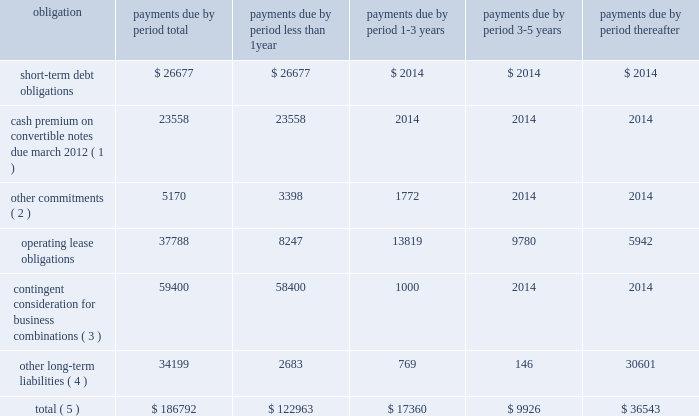Contractual cash flows following is a summary of our contractual payment obligations related to our consolidated debt , contingent consideration , operating leases , other commitments and long-term liabilities at september 30 , 2011 ( see notes 9 and 13 to the consolidated financial statements contained this annual report ) , ( in thousands ) : .
( 1 ) cash premiums related to the 201cif converted 201d value of the 2007 convertible notes that exceed aggregate principal balance using the closing stock price of $ 17.96 on september 30 , 2011 .
The actual amount of the cash premium will be calculated based on the 20 day average stock price prior to maturity .
A $ 1.00 change in our stock price would change the 201cif converted 201d value of the cash premium of the total aggregate principle amount of the remaining convertible notes by approximately $ 2.8 million .
( 2 ) other commitments consist of contractual license and royalty payments , and other purchase obligations .
( 3 ) contingent consideration related to business combinations is recorded at fair value and actual results could differ .
( 4 ) other long-term liabilities includes our gross unrecognized tax benefits , as well as executive deferred compensation which are both classified as beyond five years due to the uncertain nature of the commitment .
( 5 ) amounts do not include potential cash payments for the pending acquisition of aati .
Critical accounting estimates the discussion and analysis of our financial condition and results of operations are based upon our consolidated financial statements , which have been prepared in accordance with gaap .
The preparation of these financial statements requires us to make estimates and judgments that affect the reported amounts of assets , liabilities , revenues and expenses , and related disclosure of contingent assets and liabilities .
The sec has defined critical accounting policies as those that are both most important to the portrayal of our financial condition and results and which require our most difficult , complex or subjective judgments or estimates .
Based on this definition , we believe our critical accounting policies include the policies of revenue recognition , allowance for doubtful accounts , inventory valuation , business combinations , valuation of long-lived assets , share-based compensation , income taxes , goodwill and intangibles , and loss contingencies .
On an ongoing basis , we evaluate the judgments and estimates underlying all of our accounting policies .
These estimates and the underlying assumptions affect the amounts of assets and liabilities reported , disclosures , and reported amounts of revenues and expenses .
These estimates and assumptions are based on our best judgments .
We evaluate our estimates and assumptions using historical experience and other factors , including the current economic environment , which we believe to be reasonable under the circumstances .
We adjust such estimates and assumptions when facts and circumstances dictate .
As future events and their effects cannot be determined with precision , actual results could differ significantly from these estimates .
Page 80 skyworks / annual report 2011 .
What was the percent of the total contractual payment obligations that was associated with operating lease obligations? 
Computations: (37788 / 186792)
Answer: 0.2023. Contractual cash flows following is a summary of our contractual payment obligations related to our consolidated debt , contingent consideration , operating leases , other commitments and long-term liabilities at september 30 , 2011 ( see notes 9 and 13 to the consolidated financial statements contained this annual report ) , ( in thousands ) : .
( 1 ) cash premiums related to the 201cif converted 201d value of the 2007 convertible notes that exceed aggregate principal balance using the closing stock price of $ 17.96 on september 30 , 2011 .
The actual amount of the cash premium will be calculated based on the 20 day average stock price prior to maturity .
A $ 1.00 change in our stock price would change the 201cif converted 201d value of the cash premium of the total aggregate principle amount of the remaining convertible notes by approximately $ 2.8 million .
( 2 ) other commitments consist of contractual license and royalty payments , and other purchase obligations .
( 3 ) contingent consideration related to business combinations is recorded at fair value and actual results could differ .
( 4 ) other long-term liabilities includes our gross unrecognized tax benefits , as well as executive deferred compensation which are both classified as beyond five years due to the uncertain nature of the commitment .
( 5 ) amounts do not include potential cash payments for the pending acquisition of aati .
Critical accounting estimates the discussion and analysis of our financial condition and results of operations are based upon our consolidated financial statements , which have been prepared in accordance with gaap .
The preparation of these financial statements requires us to make estimates and judgments that affect the reported amounts of assets , liabilities , revenues and expenses , and related disclosure of contingent assets and liabilities .
The sec has defined critical accounting policies as those that are both most important to the portrayal of our financial condition and results and which require our most difficult , complex or subjective judgments or estimates .
Based on this definition , we believe our critical accounting policies include the policies of revenue recognition , allowance for doubtful accounts , inventory valuation , business combinations , valuation of long-lived assets , share-based compensation , income taxes , goodwill and intangibles , and loss contingencies .
On an ongoing basis , we evaluate the judgments and estimates underlying all of our accounting policies .
These estimates and the underlying assumptions affect the amounts of assets and liabilities reported , disclosures , and reported amounts of revenues and expenses .
These estimates and assumptions are based on our best judgments .
We evaluate our estimates and assumptions using historical experience and other factors , including the current economic environment , which we believe to be reasonable under the circumstances .
We adjust such estimates and assumptions when facts and circumstances dictate .
As future events and their effects cannot be determined with precision , actual results could differ significantly from these estimates .
Page 80 skyworks / annual report 2011 .
What is the total value of operating lease obligations that are due within the next 5 years? 
Computations: (37788 - 5942)
Answer: 31846.0. 